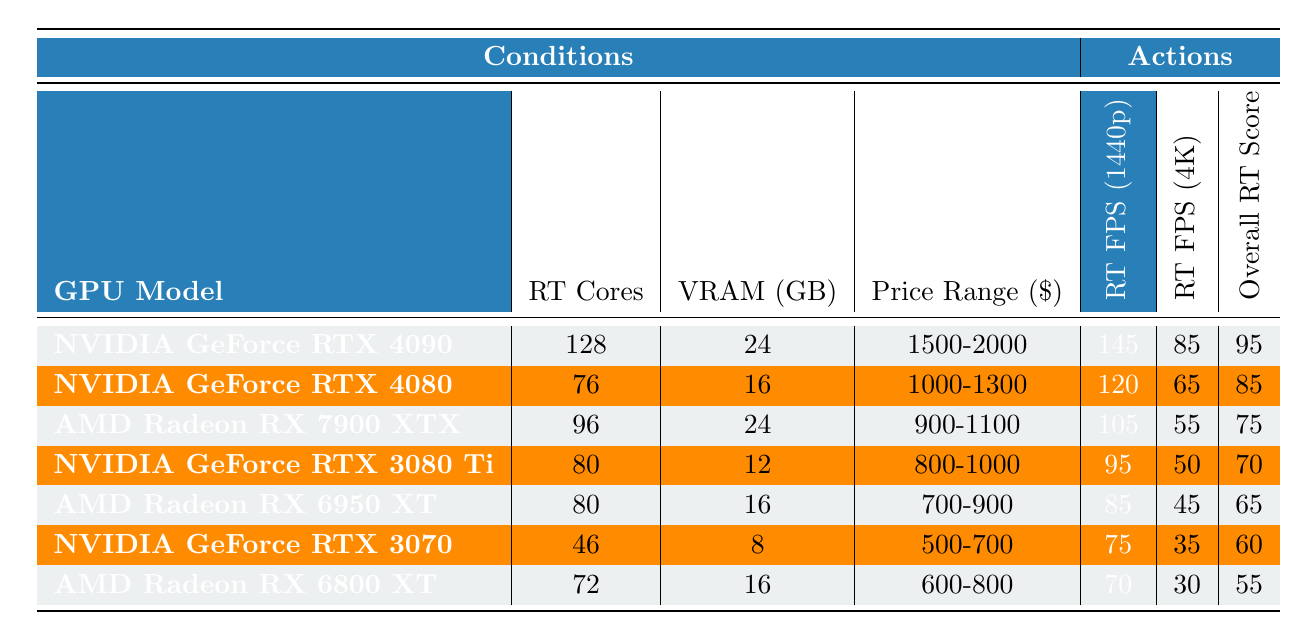Which GPU has the highest Ray Tracing FPS at 1440p? The table shows that the NVIDIA GeForce RTX 4090 has the highest Ray Tracing FPS at 1440p, with a value of 145.
Answer: NVIDIA GeForce RTX 4090 What is the Overall RT Performance Score of the AMD Radeon RX 6800 XT? The table indicates that the Overall RT Performance Score of the AMD Radeon RX 6800 XT is 55.
Answer: 55 How much VRAM does the NVIDIA GeForce RTX 3070 have? According to the table, the NVIDIA GeForce RTX 3070 has 8 GB of VRAM.
Answer: 8 Is the Ray Tracing FPS at 4K for the AMD Radeon RX 7900 XTX greater than 60? The table lists the Ray Tracing FPS at 4K for the AMD Radeon RX 7900 XTX as 55, which is not greater than 60.
Answer: No What is the average Ray Tracing FPS at 1440p for all GPUs listed? To find the average, add the Ray Tracing FPS at 1440p for all GPUs: 145 + 120 + 105 + 95 + 85 + 75 + 70 = 795. There are 7 GPUs, so the average is 795/7 = 113.57.
Answer: Approximately 113.57 Which GPU offers the best price-to-performance ratio based on Ray Tracing FPS at 1440p? Examining the Ray Tracing FPS per dollar within the price range, we note that the NVIDIA GeForce RTX 4090 provides 145 FPS but is in the highest price range. Meanwhile, the AMD Radeon RX 7900 XTX provides 105 FPS in a lower price range. The RTX 4090 yields about 0.0725 FPS/dollar, while the RX 7900 XTX yields about 0.115 FPS/dollar, suggesting the RX 7900 XTX offers a better price-to-performance ratio.
Answer: AMD Radeon RX 7900 XTX How many Ray Tracing Cores does the NVIDIA GeForce RTX 4080 have? The table indicates that the NVIDIA GeForce RTX 4080 has 76 Ray Tracing Cores.
Answer: 76 Which GPU has the lowest Ray Tracing FPS at 4K? According to the table, the NVIDIA GeForce RTX 3070 has the lowest Ray Tracing FPS at 4K with a value of 35.
Answer: NVIDIA GeForce RTX 3070 